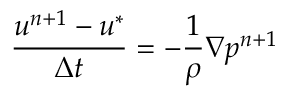Convert formula to latex. <formula><loc_0><loc_0><loc_500><loc_500>\frac { u ^ { n + 1 } - u ^ { * } } { \Delta t } = - \frac { 1 } { \rho } \nabla p ^ { n + 1 }</formula> 